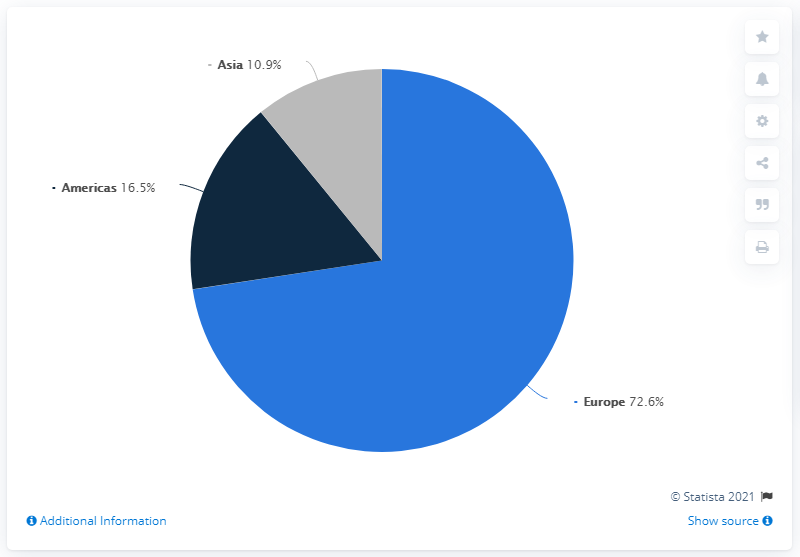Specify some key components in this picture. The region that contributes the highest revenue is Europe. IKEA's sales in Asia accounted for almost 11% of the company's total sales in 2020. The largest and smallest pies have a combined area of 61.7... units. 